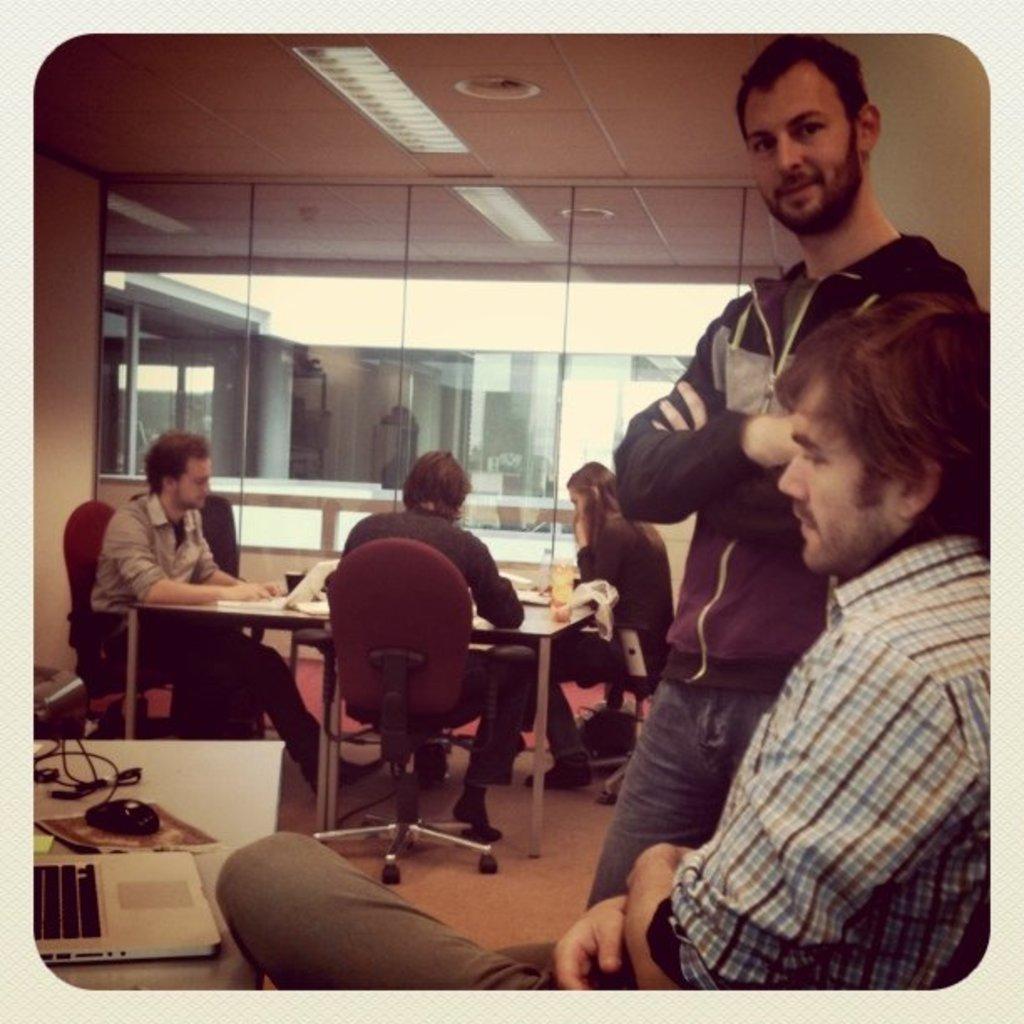Could you give a brief overview of what you see in this image? Here we can see few persons sitting on chairs in front of a table and on the table we can see a laptop, mouse and a mouse pad. Here we can see one man standing beside to this man. This is a floor. We can see the reflection here on the glass. This is a light. 